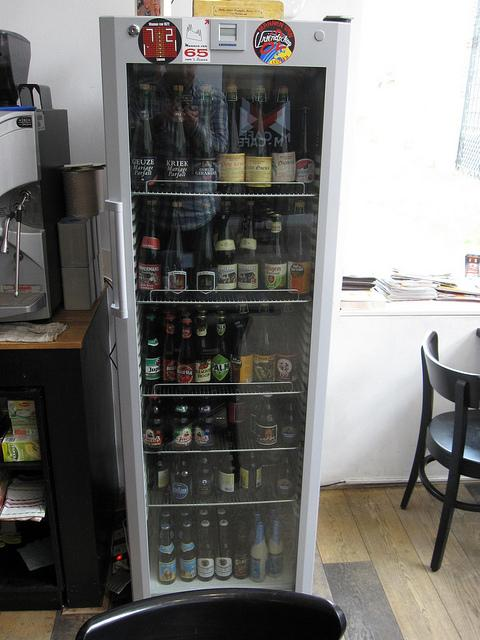What drink has the owner of this cooler stocked up on? Please explain your reasoning. water. All the beverages in the cooler are alcoholic. 